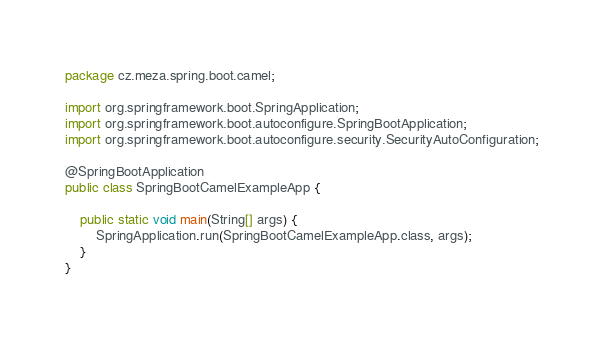<code> <loc_0><loc_0><loc_500><loc_500><_Java_>package cz.meza.spring.boot.camel;

import org.springframework.boot.SpringApplication;
import org.springframework.boot.autoconfigure.SpringBootApplication;
import org.springframework.boot.autoconfigure.security.SecurityAutoConfiguration;

@SpringBootApplication
public class SpringBootCamelExampleApp {

	public static void main(String[] args) {
		SpringApplication.run(SpringBootCamelExampleApp.class, args);
	}
}
</code> 